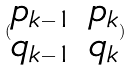<formula> <loc_0><loc_0><loc_500><loc_500>( \begin{matrix} p _ { k - 1 } & p _ { k } \\ q _ { k - 1 } & q _ { k } \end{matrix} )</formula> 